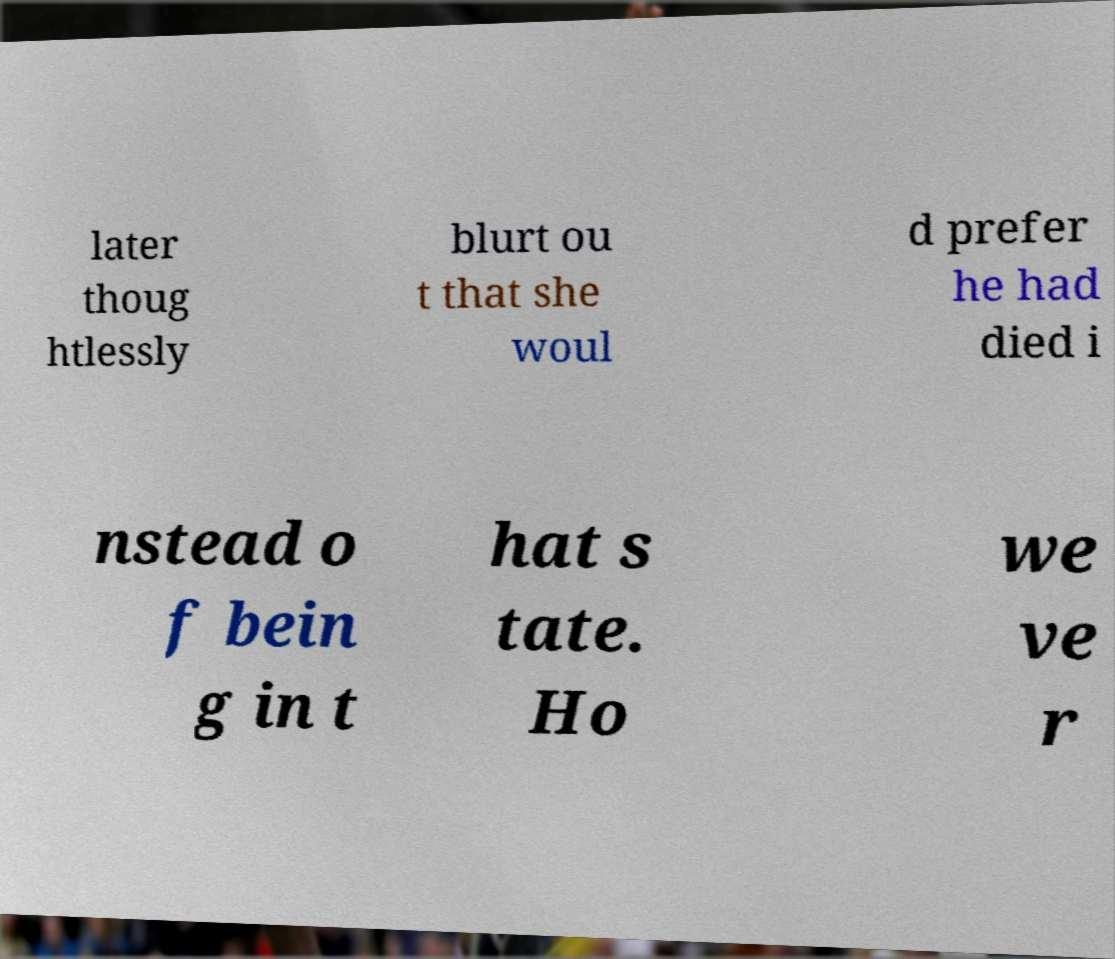Could you assist in decoding the text presented in this image and type it out clearly? later thoug htlessly blurt ou t that she woul d prefer he had died i nstead o f bein g in t hat s tate. Ho we ve r 